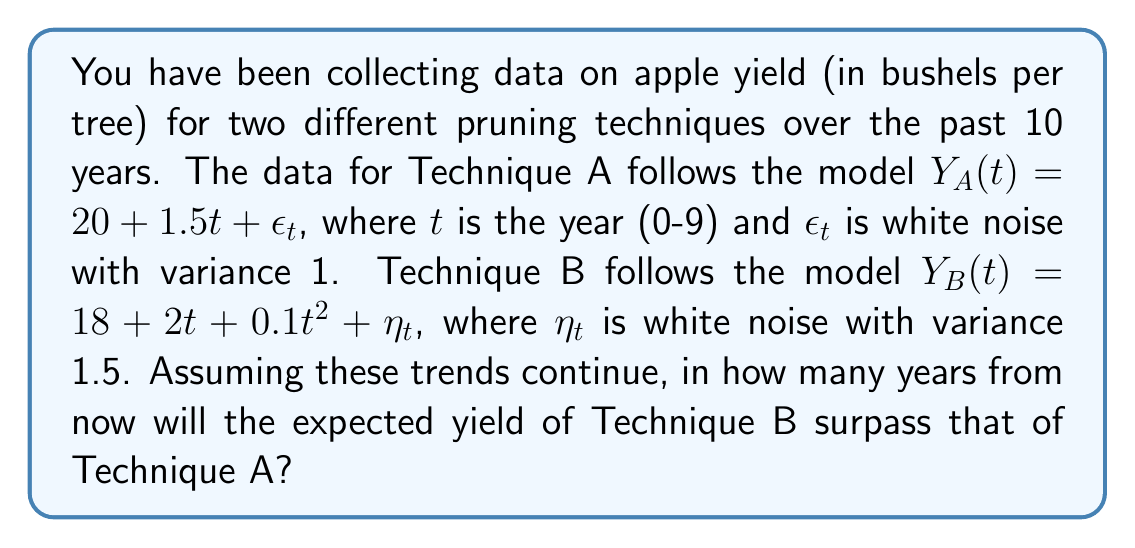Could you help me with this problem? To solve this problem, we need to follow these steps:

1) First, let's write out the expected yield functions for both techniques, ignoring the noise terms:

   Technique A: $E[Y_A(t)] = 20 + 1.5t$
   Technique B: $E[Y_B(t)] = 18 + 2t + 0.1t^2$

2) We want to find when these are equal, so we set up the equation:

   $20 + 1.5t = 18 + 2t + 0.1t^2$

3) Rearrange the equation:

   $0.1t^2 + 0.5t - 2 = 0$

4) This is a quadratic equation. We can solve it using the quadratic formula:

   $t = \frac{-b \pm \sqrt{b^2 - 4ac}}{2a}$

   Where $a = 0.1$, $b = 0.5$, and $c = -2$

5) Plugging in these values:

   $t = \frac{-0.5 \pm \sqrt{0.5^2 - 4(0.1)(-2)}}{2(0.1)}$

   $= \frac{-0.5 \pm \sqrt{0.25 + 0.8}}{0.2}$

   $= \frac{-0.5 \pm \sqrt{1.05}}{0.2}$

   $= \frac{-0.5 \pm 1.0247}{0.2}$

6) This gives us two solutions:

   $t_1 = \frac{-0.5 + 1.0247}{0.2} = 2.6235$

   $t_2 = \frac{-0.5 - 1.0247}{0.2} = -7.6235$

7) Since we're looking for a future time, we discard the negative solution. The positive solution tells us that Technique B will surpass Technique A after approximately 2.6235 years.

8) However, the question asks for the number of years from now, and we've already collected 10 years of data. So we need to subtract 10 from our result:

   $2.6235 - 10 = -7.3765$

9) Since this is negative, it means that Technique B has already surpassed Technique A within the 10 years of data collection.

10) To find exactly when this happened, we solve the equation again, but this time we use $t$ to represent the year within our 10-year dataset:

    $20 + 1.5t = 18 + 2t + 0.1t^2$

    Solving this as before, we get $t \approx 2.6235$

Therefore, Technique B surpassed Technique A approximately 2.6235 years into our 10-year dataset, or about 7.3765 years ago.
Answer: Technique B has already surpassed Technique A approximately 7.4 years ago. 